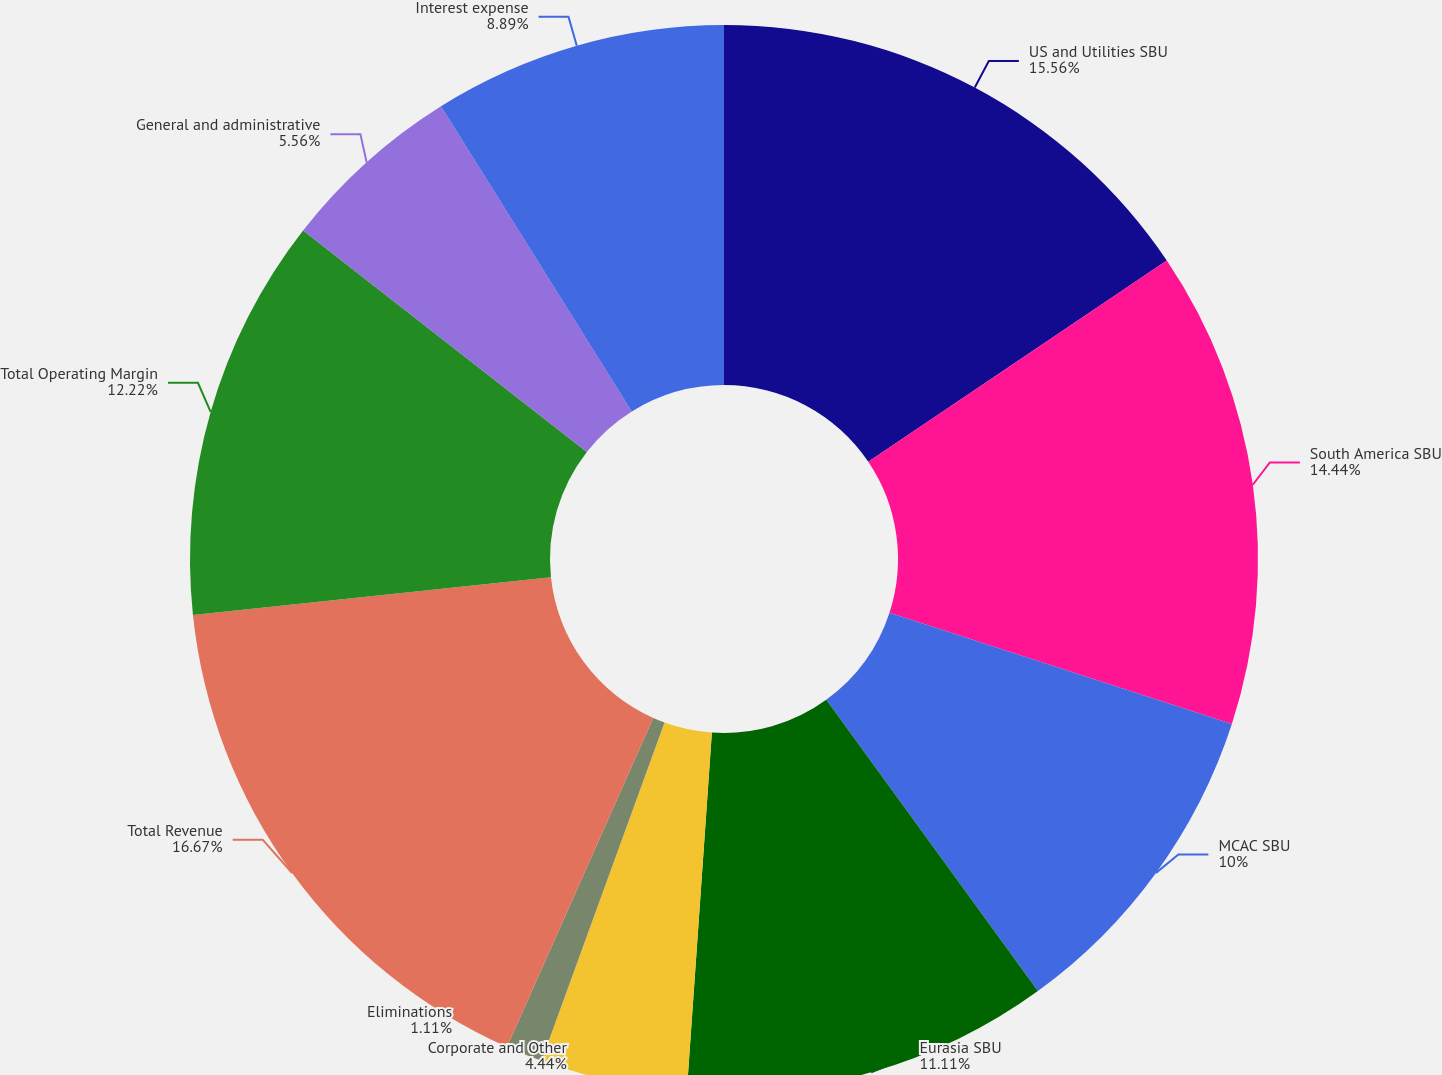Convert chart. <chart><loc_0><loc_0><loc_500><loc_500><pie_chart><fcel>US and Utilities SBU<fcel>South America SBU<fcel>MCAC SBU<fcel>Eurasia SBU<fcel>Corporate and Other<fcel>Eliminations<fcel>Total Revenue<fcel>Total Operating Margin<fcel>General and administrative<fcel>Interest expense<nl><fcel>15.56%<fcel>14.44%<fcel>10.0%<fcel>11.11%<fcel>4.44%<fcel>1.11%<fcel>16.67%<fcel>12.22%<fcel>5.56%<fcel>8.89%<nl></chart> 